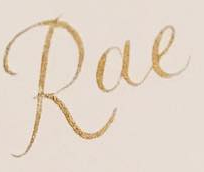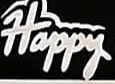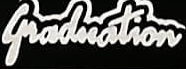What words can you see in these images in sequence, separated by a semicolon? Rae; Happy; Graduation 